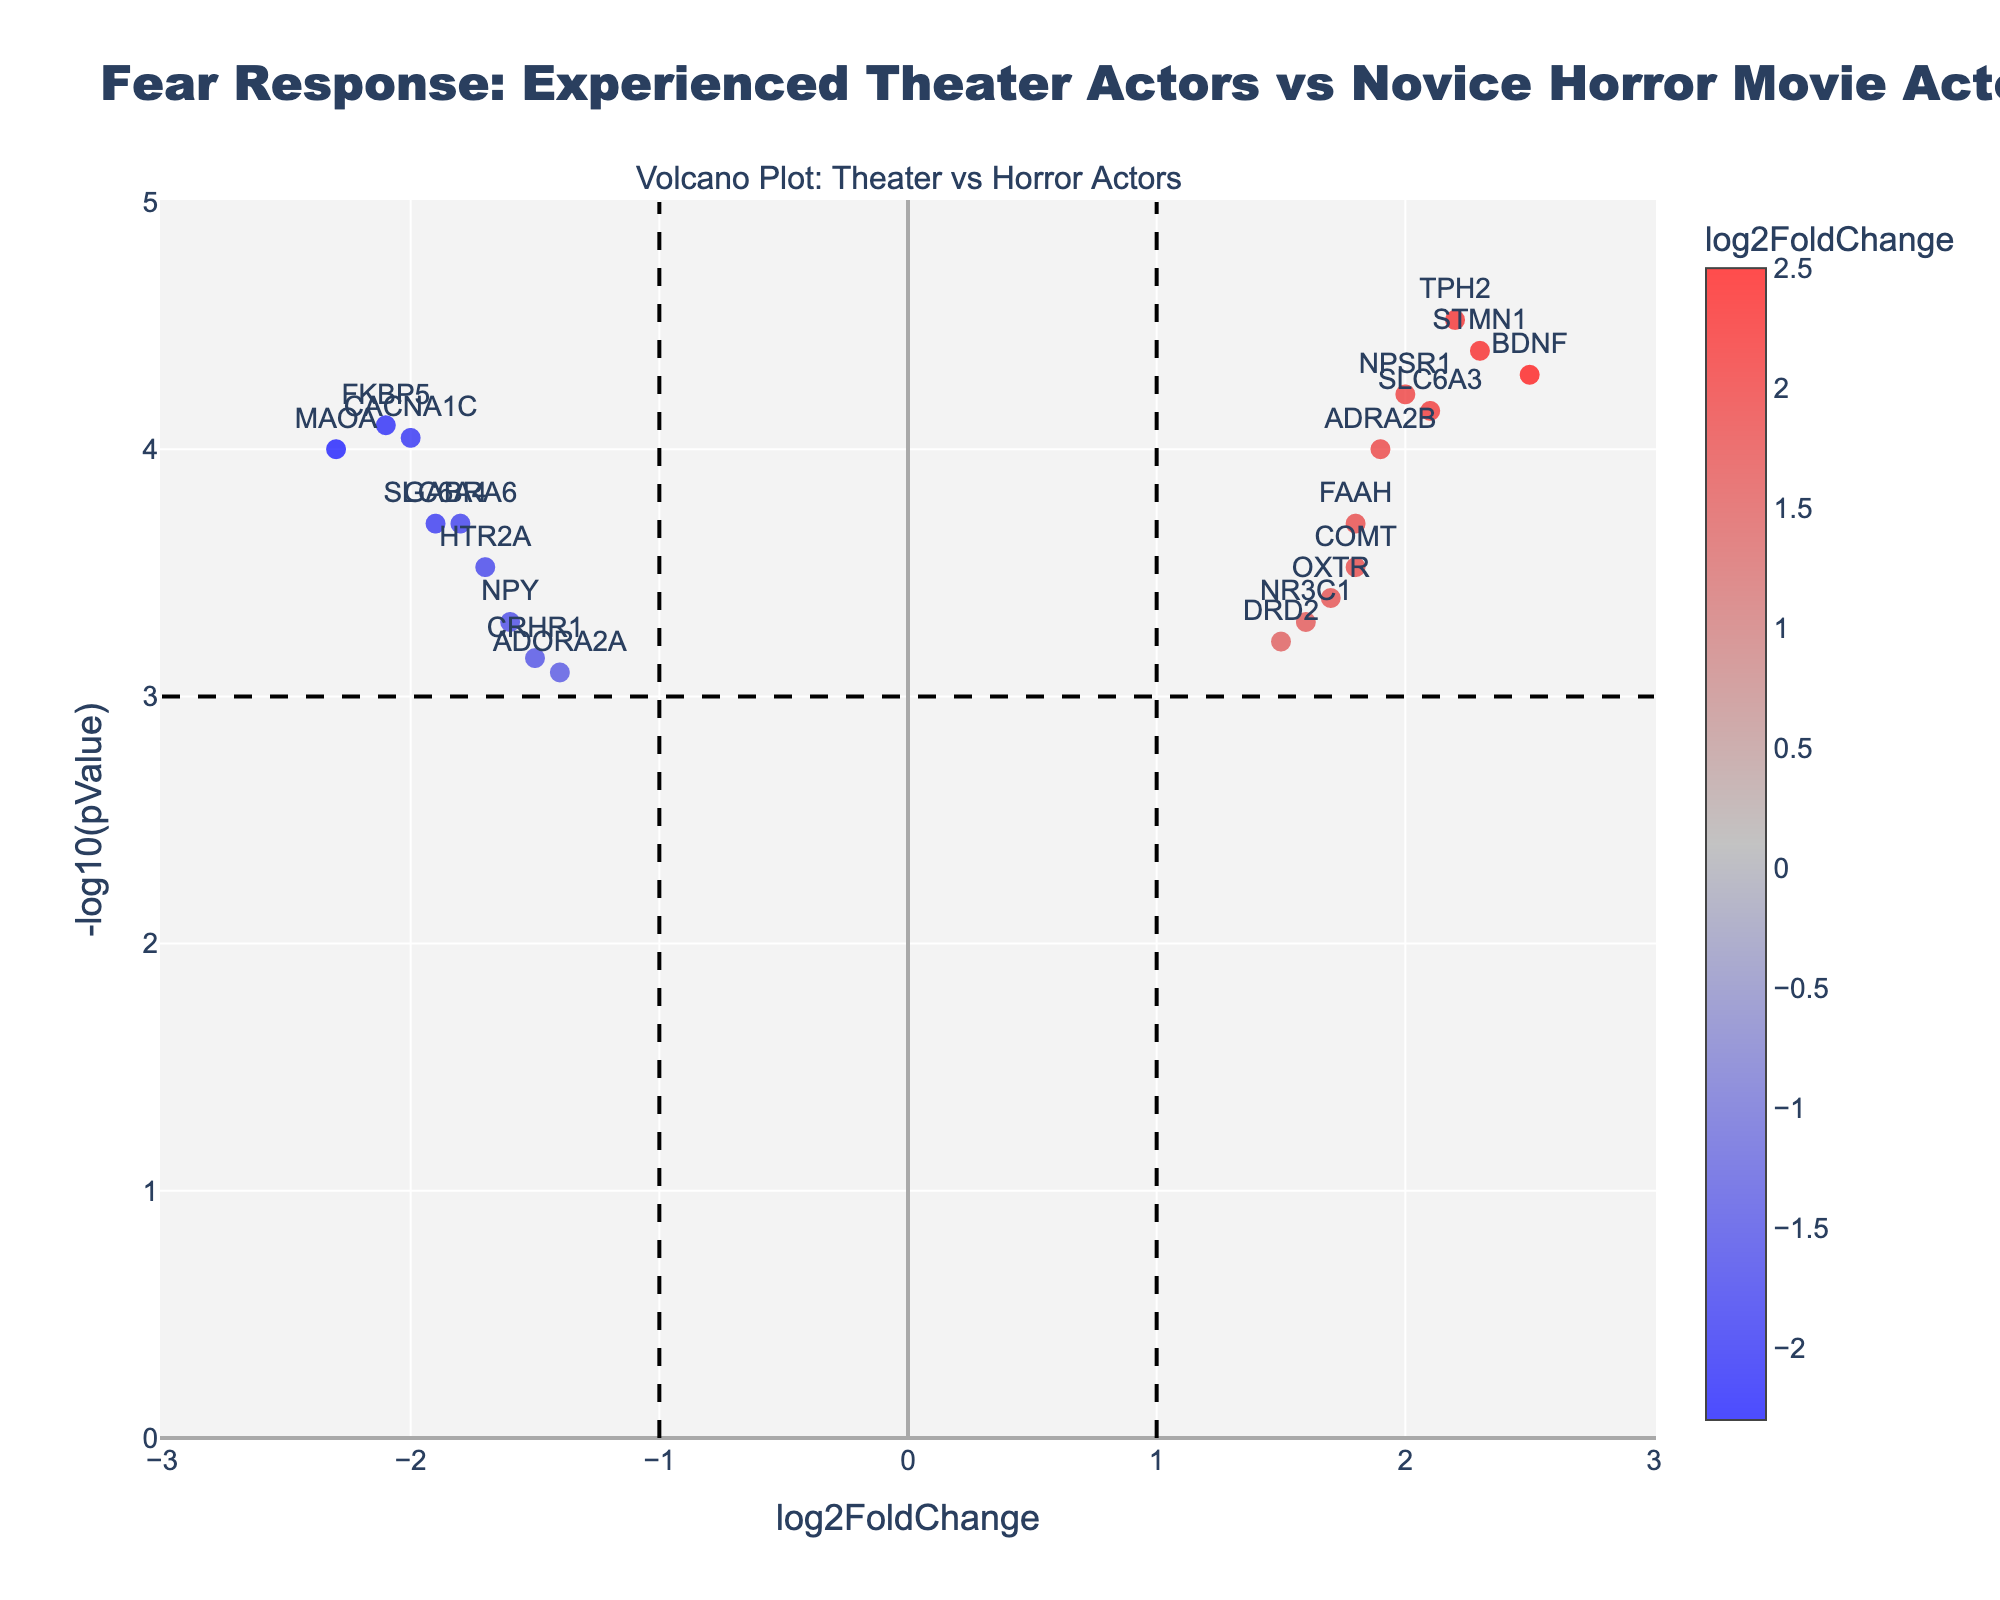What is the title of the plot? The title is located at the top of the plot and gives a brief description of what the plot represents.
Answer: Fear Response: Experienced Theater Actors vs Novice Horror Movie Actors Which gene has the highest -log10(pValue)? To find this, look at the y-axis which represents -log10(pValue). The gene with the highest point on this axis has the highest -log10(pValue).
Answer: BDNF Which genes are highly up-regulated (log2FoldChange > 1 and -log10(pValue) > 3)? Genes that meet both criteria can be found in the top-right quadrant of the plot, where -log10(pValue) > 3 and log2FoldChange > 1.
Answer: BDNF, TPH2, STMN1 Which gene has the lowest log2FoldChange? To determine this, look at the x-axis which shows log2FoldChange. The gene with the most negative value on this axis has the lowest log2FoldChange.
Answer: MAOA How many genes have a fold change greater than 2? Look for genes in the plot on the far right (log2FoldChange > 2). Count the number of points in this region.
Answer: 3 (BDNF, TPH2, STMN1) Which genes are down-regulated and highly significant (log2FoldChange < -1 and -log10(pValue) > 3)? Genes that fulfill these criteria are found in the top-left quadrant of the plot, where -log10(pValue) > 3 and log2FoldChange < -1.
Answer: MAOA, FKBP5, CACNA1C What is the log2FoldChange and -log10(pValue) of the gene COMT? The gene COMT's values can be found by locating it on the plot and noting its position on both axes.
Answer: log2FoldChange: 1.8, -log10(pValue): 3.52 Compare the significance of genes COMT and FAAH. To compare their significance, look at their -log10(pValue) values on the y-axis.
Answer: COMT is more significant (higher -log10(pValue)) Would you consider the gene SLC6A3 up-regulated, down-regulated, or neutral, and highly significant or not? To determine this, look at both the log2FoldChange (x-axis) and -log10(pValue) (y-axis). Up-regulated genes have log2FoldChange > 0 and highly significant genes have -log10(pValue) > 3.
Answer: Up-regulated and highly significant Is there a gene with both log2FoldChange greater than 2 and -log10(pValue) less than 3? Examine the plot's x-axis for log2FoldChange > 2, and check if any of these points fall below the horizontal line at -log10(pValue) = 3.
Answer: No 